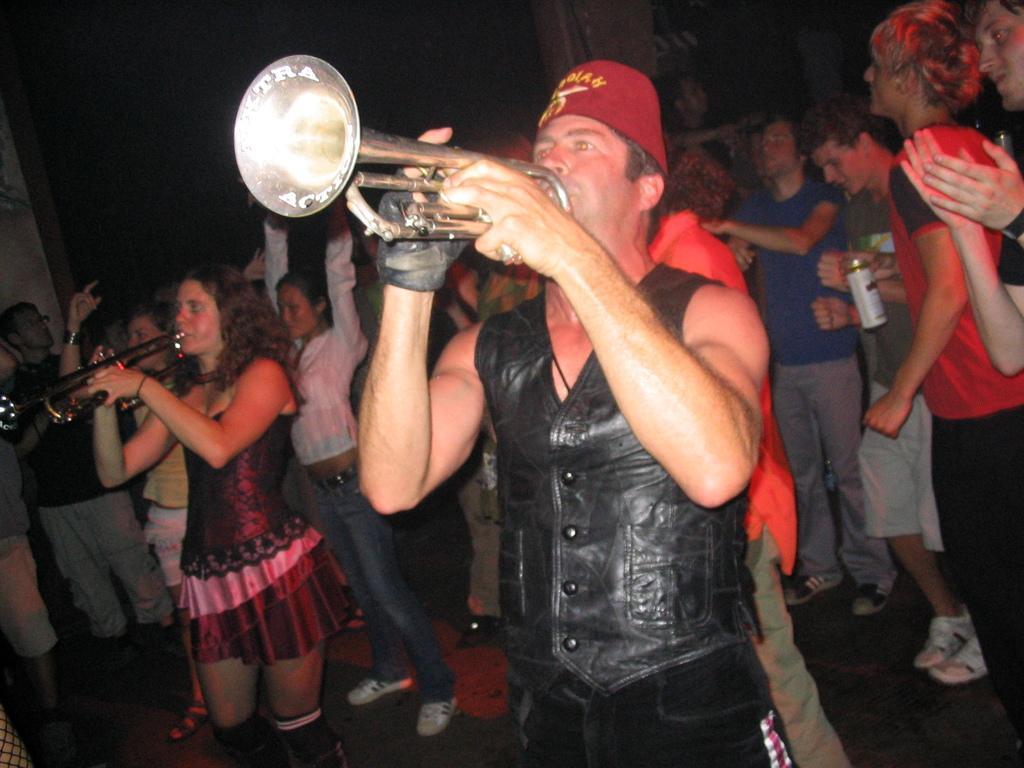In one or two sentences, can you explain what this image depicts? In the image in the center we can see two persons were standing and playing trumpet. In the background we can see wall and group of people were standing and holding some objects. 